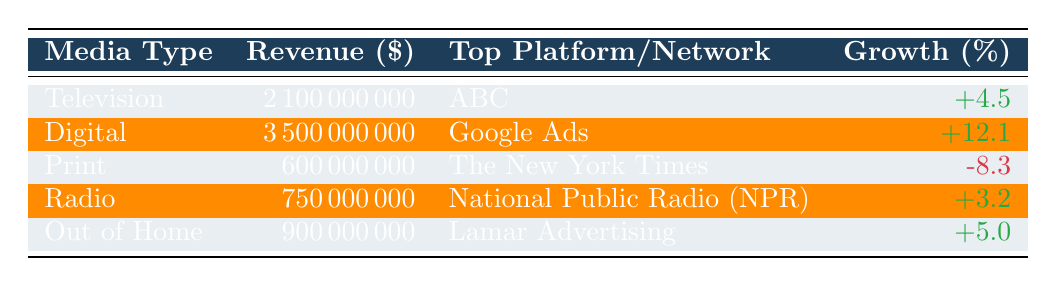What was the total advertising revenue for all media types combined? To find the total advertising revenue, we need to sum the revenue of all media types: 2,100,000,000 (Television) + 3,500,000,000 (Digital) + 600,000,000 (Print) + 750,000,000 (Radio) + 900,000,000 (Out of Home) = 8,850,000,000.
Answer: 8,850,000,000 Which media type had the highest revenue in Q3 2023? Looking at the revenue column, Digital at 3,500,000,000 has the highest value compared to other media types listed.
Answer: Digital Did print advertising revenue grow or decline in Q3 2023? The growth percentage for Print is -8.3, indicating a decline in revenue since it is a negative value.
Answer: Decline What is the average growth percentage of all media types listed? To find the average growth percentage, we add all growth percentages: 4.5 + 12.1 - 8.3 + 3.2 + 5.0 = 16.5. Then we divide by the number of media types (5): 16.5 / 5 = 3.3.
Answer: 3.3 Which media type experienced the most significant growth in Q3 2023? By comparing the growth percentages, Digital at +12.1 shows the highest increase compared to others.
Answer: Digital 